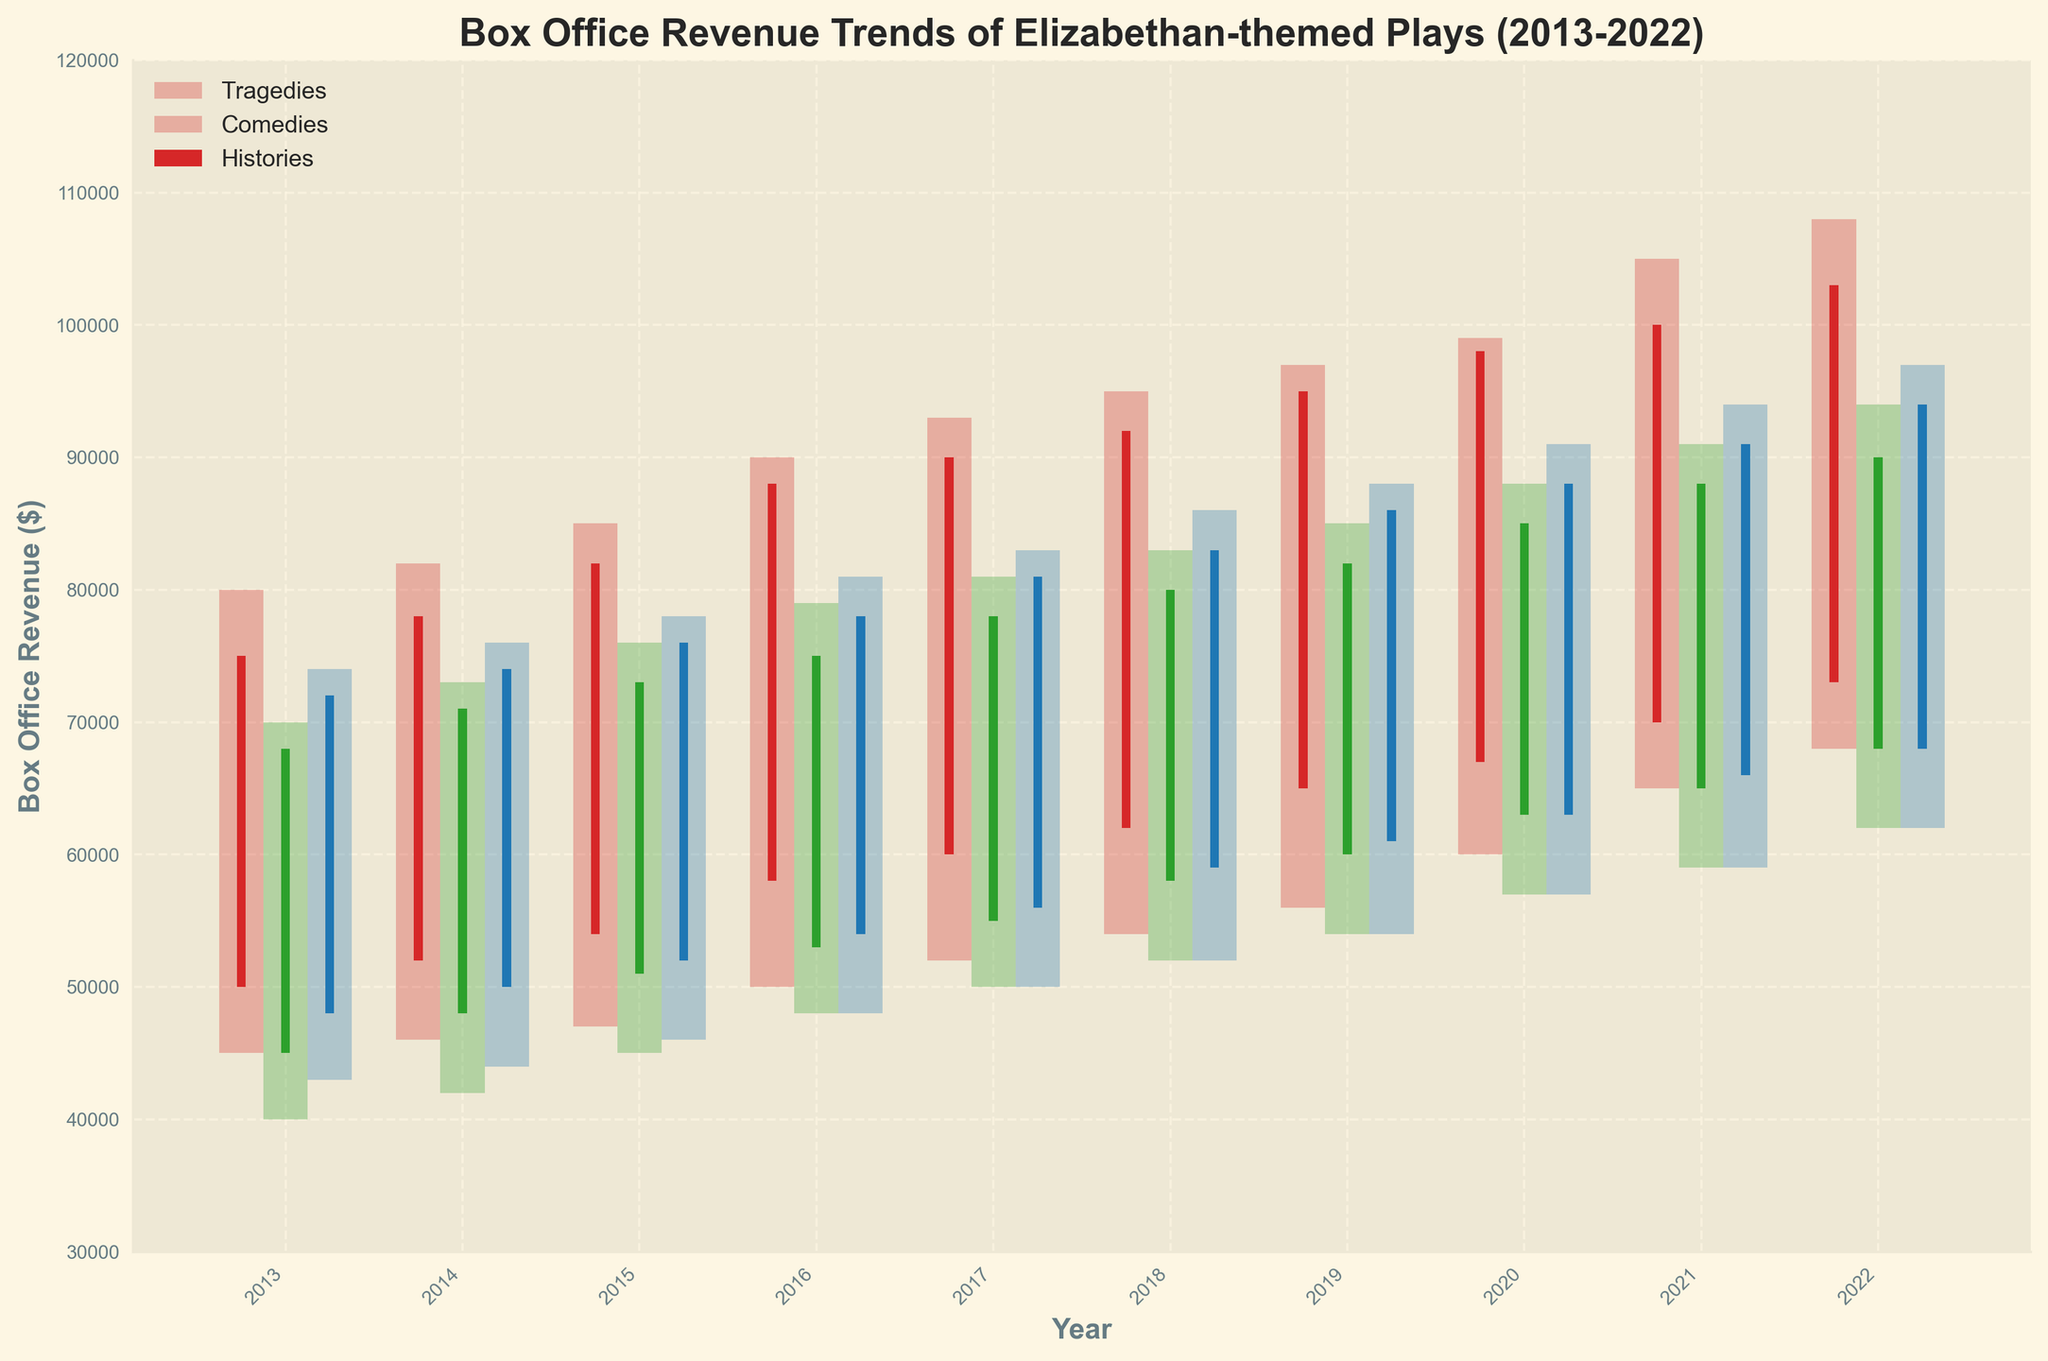What is the title of the plot? The title is located at the top of the plot and describes the overall content. The title reads 'Box Office Revenue Trends of Elizabethan-themed Plays (2013-2022)'.
Answer: Box Office Revenue Trends of Elizabethan-themed Plays (2013-2022) What are the three genres analyzed in the plot? The genres are indicated in the legend on the plot. They are Tragedies, Comedies, and Histories.
Answer: Tragedies, Comedies, Histories Which genre had the highest closing revenue in 2022? By looking at the topmost point of the three different bars for 2022, we see that Tragedies had the highest closing revenue, reaching 103,000 dollars.
Answer: Tragedies What is the trend in box office revenue for Tragedies from 2013 to 2022? The revenue for Tragedies increased steadily over the years. Starting from 75,000 dollars in 2013 and closing at 103,000 dollars in 2022.
Answer: Increasing Which year had the lowest opening revenue for Comedies, and what was the amount? By examining the lowest point of each candle corresponding to Comedies, we see that 2013 had the lowest opening revenue, which was 45,000 dollars.
Answer: 2013, 45,000 dollars How does the range between high and low revenue for Histories in 2019 compare to 2022? For 2019, the range is from 54,000 to 88,000 dollars, which is 34,000 dollars. For 2022, the range is from 62,000 to 97,000 dollars, which is 35,000 dollars. Thus, the range increased slightly in 2022 compared to 2019.
Answer: Increased by 1,000 dollars What is the general pattern for the differences between opening and closing revenues for Comedies across the decade? Each bar shows that the closing revenue is generally higher than the opening revenue every year, which indicates growth in box office revenue over time.
Answer: Generally increasing Which genre showed the most significant increase in the high revenue value from 2013 to 2022? By comparing the high revenues of all genres, Tragedies increased from 80,000 dollars in 2013 to 108,000 dollars in 2022, which is a 28,000 dollar increase, the largest among the genres.
Answer: Tragedies During which year did all three genres have the same order of closed revenue, and what was that order? By inspecting the bars, in 2020, the closed revenues were in descending order: Tragedies with 98,000 dollars, Comedies with 85,000 dollars, and Histories with 88,000 dollars.
Answer: 2020, Tragedies > Histories > Comedies 